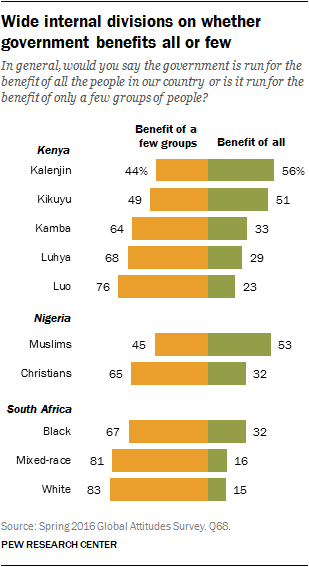Draw attention to some important aspects in this diagram. The median of green bars in Kenya, multiplied by 2, is compared to the median of orange bars in Kenya. The result is greater if it is greater than the median of orange bars in Kenya. According to a survey conducted in Nigeria, a significant percentage of Muslims hold the view that "Benefit of all" is important. Specifically, 53% of Muslims in Nigeria hold this view. 